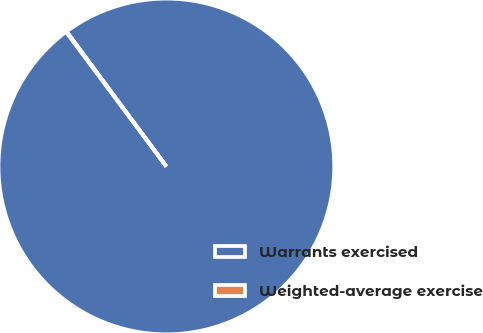Convert chart. <chart><loc_0><loc_0><loc_500><loc_500><pie_chart><fcel>Warrants exercised<fcel>Weighted-average exercise<nl><fcel>99.94%<fcel>0.06%<nl></chart> 